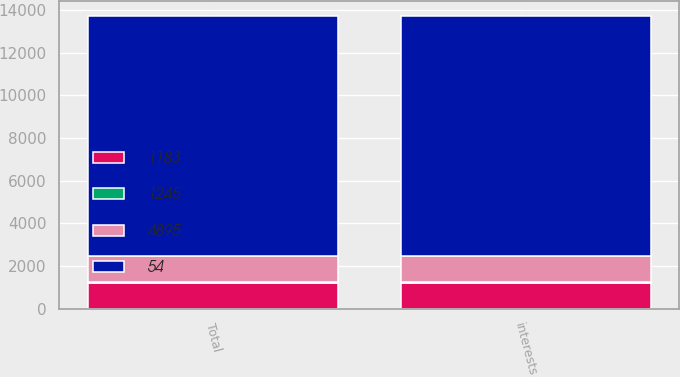Convert chart. <chart><loc_0><loc_0><loc_500><loc_500><stacked_bar_chart><ecel><fcel>interests<fcel>Total<nl><fcel>54<fcel>11243<fcel>11243<nl><fcel>4895<fcel>1245<fcel>1245<nl><fcel>1245<fcel>49<fcel>54<nl><fcel>1183<fcel>1183<fcel>1183<nl></chart> 